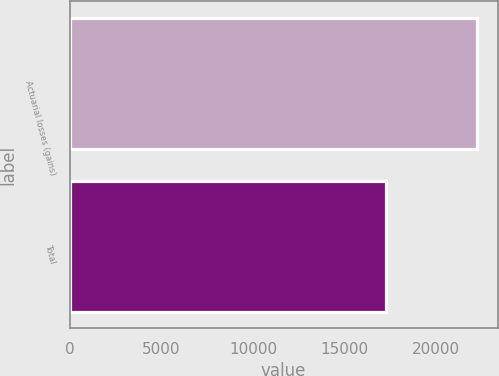Convert chart. <chart><loc_0><loc_0><loc_500><loc_500><bar_chart><fcel>Actuarial losses (gains)<fcel>Total<nl><fcel>22236<fcel>17252<nl></chart> 